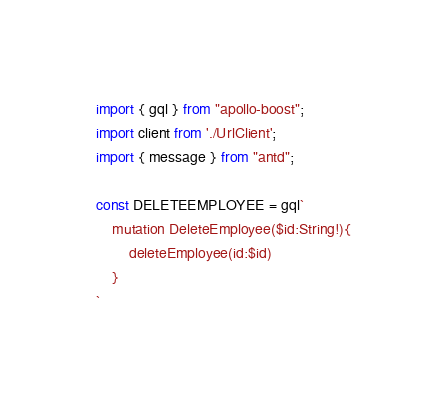<code> <loc_0><loc_0><loc_500><loc_500><_TypeScript_>import { gql } from "apollo-boost";
import client from './UrlClient';
import { message } from "antd";

const DELETEEMPLOYEE = gql`
    mutation DeleteEmployee($id:String!){
        deleteEmployee(id:$id)
    }
`</code> 